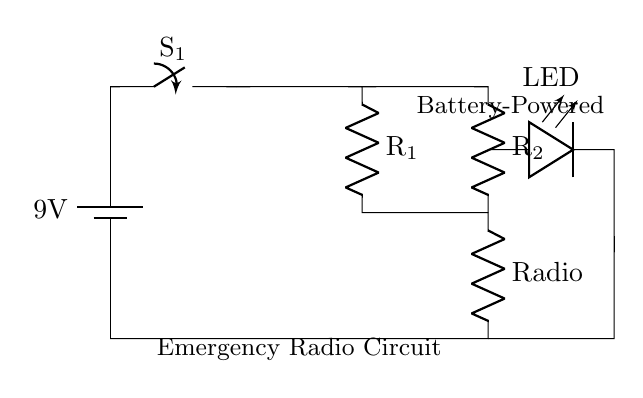What is the voltage of the battery? The battery in the circuit is labeled with a voltage of 9 volts. This information is directly indicated on the circuit as part of the battery component.
Answer: 9 volts What does the switch do in this circuit? The switch, labeled as S1, is used to control the flow of electricity in the circuit. When the switch is closed, it allows current to flow, powering the radio and LED. When opened, it stops the flow.
Answer: Control the flow of electricity What component is represented by R1? R1 in the circuit is labeled as a resistor, which is often used to limit the current flowing to the radio component, helping to protect it from excessive current.
Answer: Resistor How many resistors are present in the circuit? The circuit diagram contains two resistors, labeled R1 and R2, serving different functions in relation to the radio and the LED.
Answer: Two What is the function of the LED in this circuit? The LED, which is connected parallel to R2, serves as an indicator light that shows whether the circuit is active. If the circuit is powered, the LED will illuminate.
Answer: Indicator light What happens when the switch is closed? When the switch S1 is closed, it completes the circuit allowing current to flow from the battery through R1 to the radio and through R2 to the LED, which will illuminate.
Answer: Circuit completes and powers devices What component is directly connected to the LED? The LED is directly connected to the resistor R2, which limits the current to ensure safe operation of the LED. This connection is essential for proper functioning.
Answer: Resistor R2 